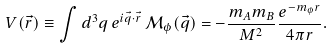<formula> <loc_0><loc_0><loc_500><loc_500>V ( \vec { r } ) \equiv \int d ^ { 3 } q \, e ^ { i \vec { q } \cdot \vec { r } } \, \mathcal { M } _ { \phi } ( \vec { q } ) = - \frac { m _ { A } m _ { B } } { M ^ { 2 } } \frac { e ^ { - m _ { \phi } r } } { 4 \pi r } .</formula> 